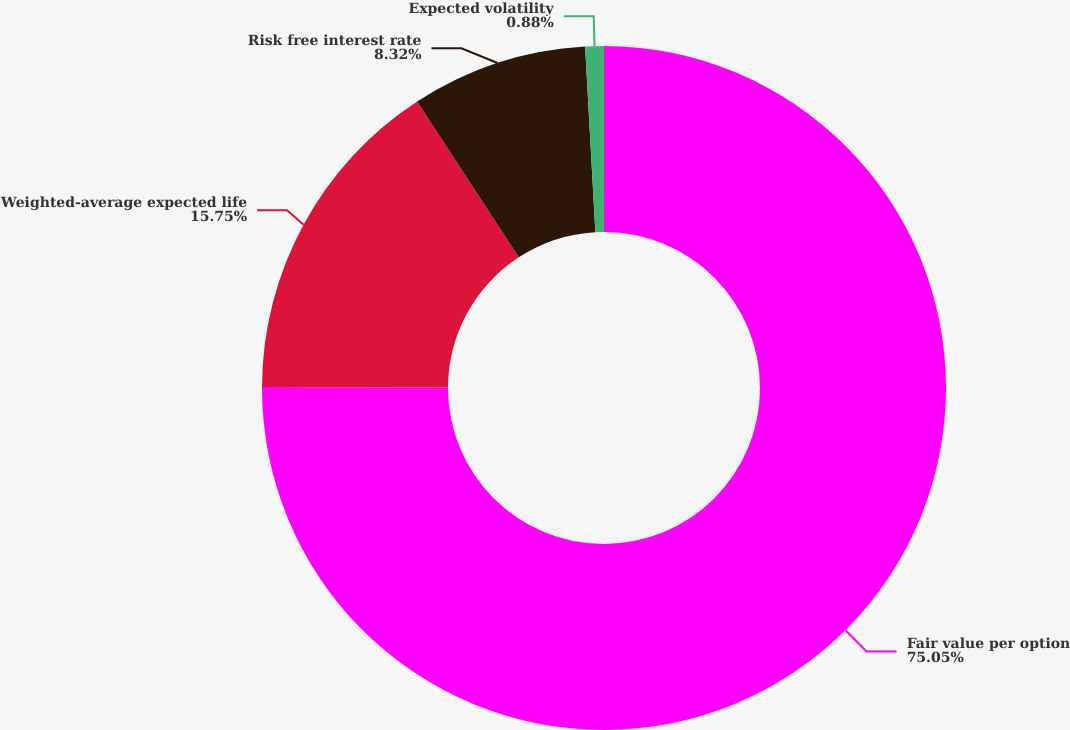<chart> <loc_0><loc_0><loc_500><loc_500><pie_chart><fcel>Fair value per option<fcel>Weighted-average expected life<fcel>Risk free interest rate<fcel>Expected volatility<nl><fcel>75.05%<fcel>15.75%<fcel>8.32%<fcel>0.88%<nl></chart> 